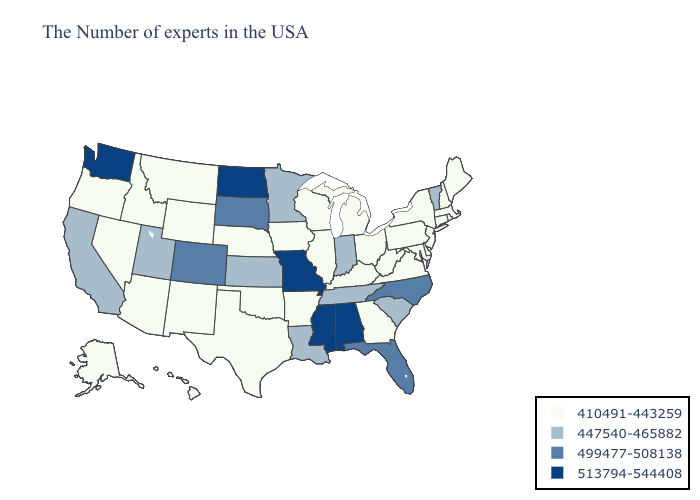Does Tennessee have the lowest value in the South?
Be succinct. No. Does Rhode Island have the highest value in the Northeast?
Concise answer only. No. What is the highest value in the South ?
Short answer required. 513794-544408. What is the value of North Carolina?
Short answer required. 499477-508138. What is the lowest value in states that border Maryland?
Quick response, please. 410491-443259. Does North Dakota have the highest value in the MidWest?
Quick response, please. Yes. Name the states that have a value in the range 447540-465882?
Give a very brief answer. Vermont, South Carolina, Indiana, Tennessee, Louisiana, Minnesota, Kansas, Utah, California. What is the lowest value in states that border Connecticut?
Short answer required. 410491-443259. Which states have the lowest value in the USA?
Concise answer only. Maine, Massachusetts, Rhode Island, New Hampshire, Connecticut, New York, New Jersey, Delaware, Maryland, Pennsylvania, Virginia, West Virginia, Ohio, Georgia, Michigan, Kentucky, Wisconsin, Illinois, Arkansas, Iowa, Nebraska, Oklahoma, Texas, Wyoming, New Mexico, Montana, Arizona, Idaho, Nevada, Oregon, Alaska, Hawaii. Among the states that border Maryland , which have the highest value?
Write a very short answer. Delaware, Pennsylvania, Virginia, West Virginia. What is the value of Ohio?
Quick response, please. 410491-443259. Among the states that border Maine , which have the lowest value?
Give a very brief answer. New Hampshire. Name the states that have a value in the range 499477-508138?
Quick response, please. North Carolina, Florida, South Dakota, Colorado. Name the states that have a value in the range 447540-465882?
Quick response, please. Vermont, South Carolina, Indiana, Tennessee, Louisiana, Minnesota, Kansas, Utah, California. Does Kentucky have a lower value than Alaska?
Be succinct. No. 